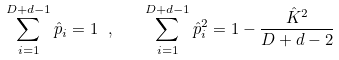Convert formula to latex. <formula><loc_0><loc_0><loc_500><loc_500>\sum _ { i = 1 } ^ { D + d - 1 } \hat { p } _ { i } = 1 \ , \quad \sum _ { i = 1 } ^ { D + d - 1 } \hat { p } _ { i } ^ { 2 } = 1 - \frac { \hat { K } ^ { 2 } } { D + d - 2 }</formula> 